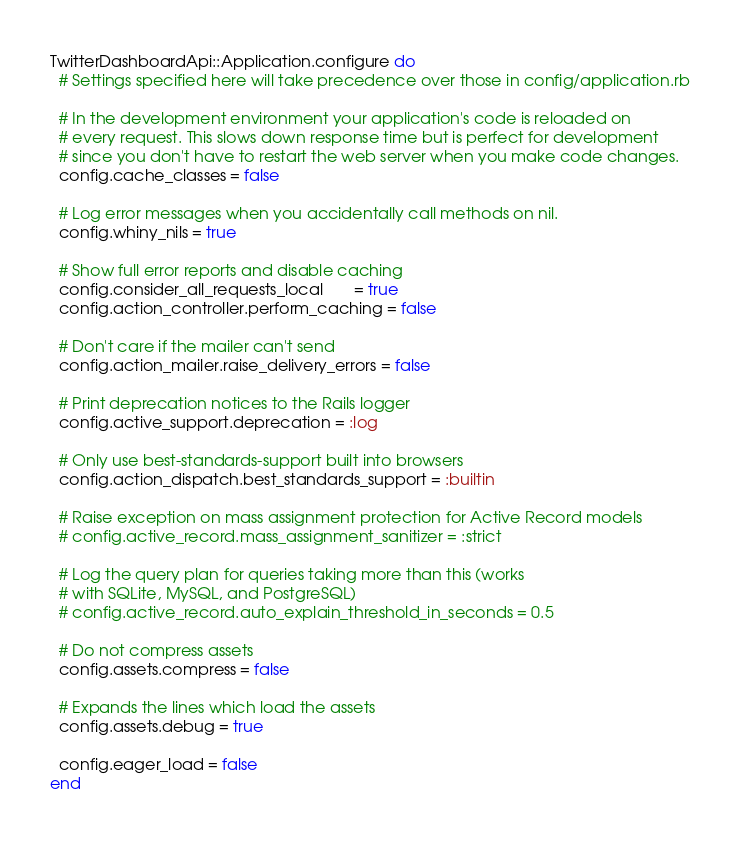<code> <loc_0><loc_0><loc_500><loc_500><_Ruby_>TwitterDashboardApi::Application.configure do
  # Settings specified here will take precedence over those in config/application.rb

  # In the development environment your application's code is reloaded on
  # every request. This slows down response time but is perfect for development
  # since you don't have to restart the web server when you make code changes.
  config.cache_classes = false

  # Log error messages when you accidentally call methods on nil.
  config.whiny_nils = true

  # Show full error reports and disable caching
  config.consider_all_requests_local       = true
  config.action_controller.perform_caching = false

  # Don't care if the mailer can't send
  config.action_mailer.raise_delivery_errors = false

  # Print deprecation notices to the Rails logger
  config.active_support.deprecation = :log

  # Only use best-standards-support built into browsers
  config.action_dispatch.best_standards_support = :builtin

  # Raise exception on mass assignment protection for Active Record models
  # config.active_record.mass_assignment_sanitizer = :strict

  # Log the query plan for queries taking more than this (works
  # with SQLite, MySQL, and PostgreSQL)
  # config.active_record.auto_explain_threshold_in_seconds = 0.5

  # Do not compress assets
  config.assets.compress = false

  # Expands the lines which load the assets
  config.assets.debug = true

  config.eager_load = false
end
</code> 